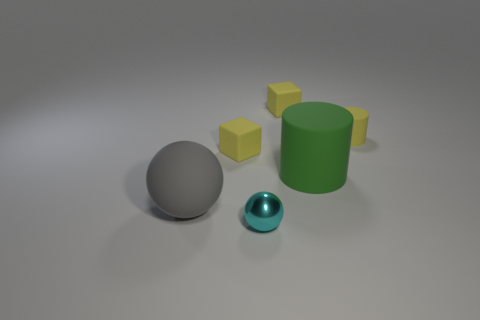Add 2 small matte cylinders. How many objects exist? 8 Subtract all cylinders. How many objects are left? 4 Add 5 small yellow blocks. How many small yellow blocks exist? 7 Subtract 0 purple cubes. How many objects are left? 6 Subtract all gray things. Subtract all gray matte balls. How many objects are left? 4 Add 2 large green cylinders. How many large green cylinders are left? 3 